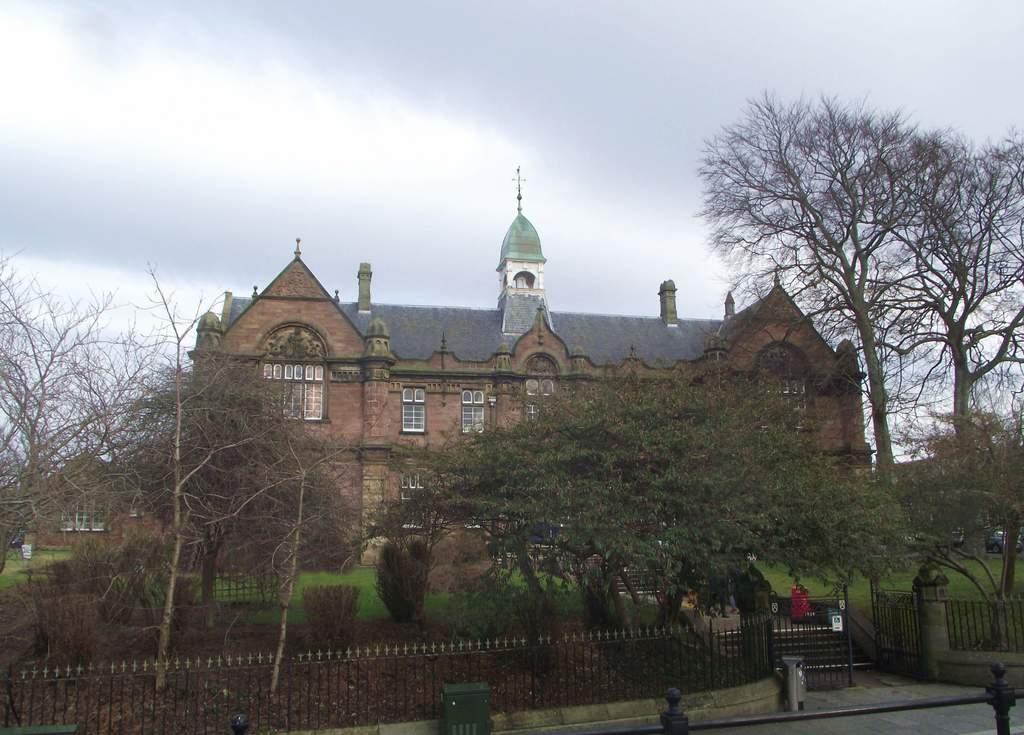Please provide a concise description of this image. In this image, we can see some houses, stairs, the fence and the ground with some objects. We can also see some grass, plants and trees. We can also see some objects at the bottom. We can also see the sky. 